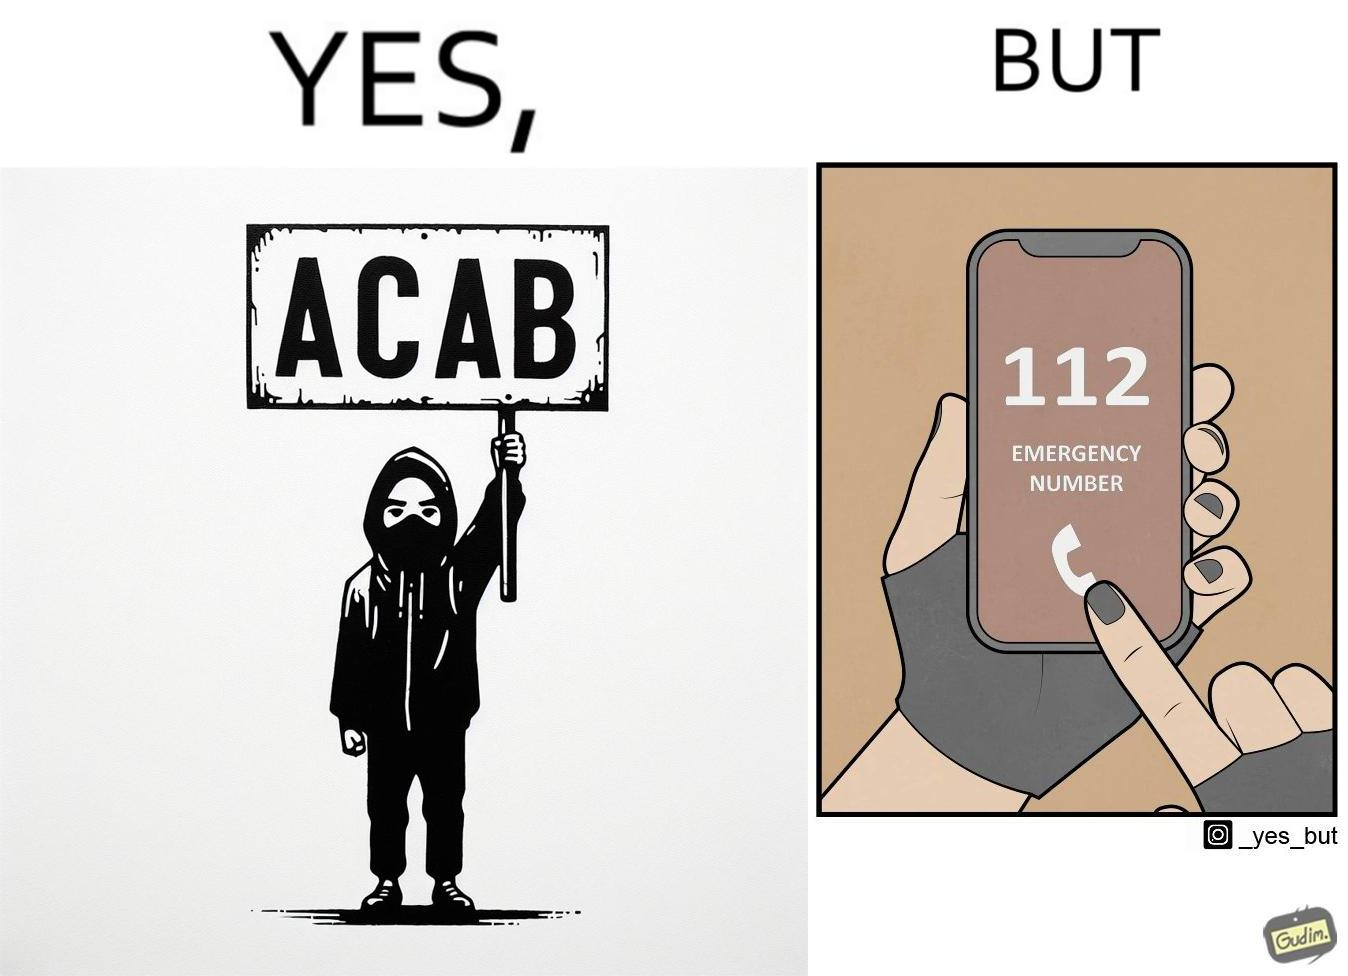Provide a description of this image. This is funny because on the one hand this person is rebelling against cops (slogan being All Cops Are Bad - ACAB), but on the other hand they are also calling the cops for help. 